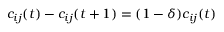<formula> <loc_0><loc_0><loc_500><loc_500>c _ { i j } ( t ) - c _ { i j } ( t + 1 ) = ( 1 - \delta ) c _ { i j } ( t )</formula> 